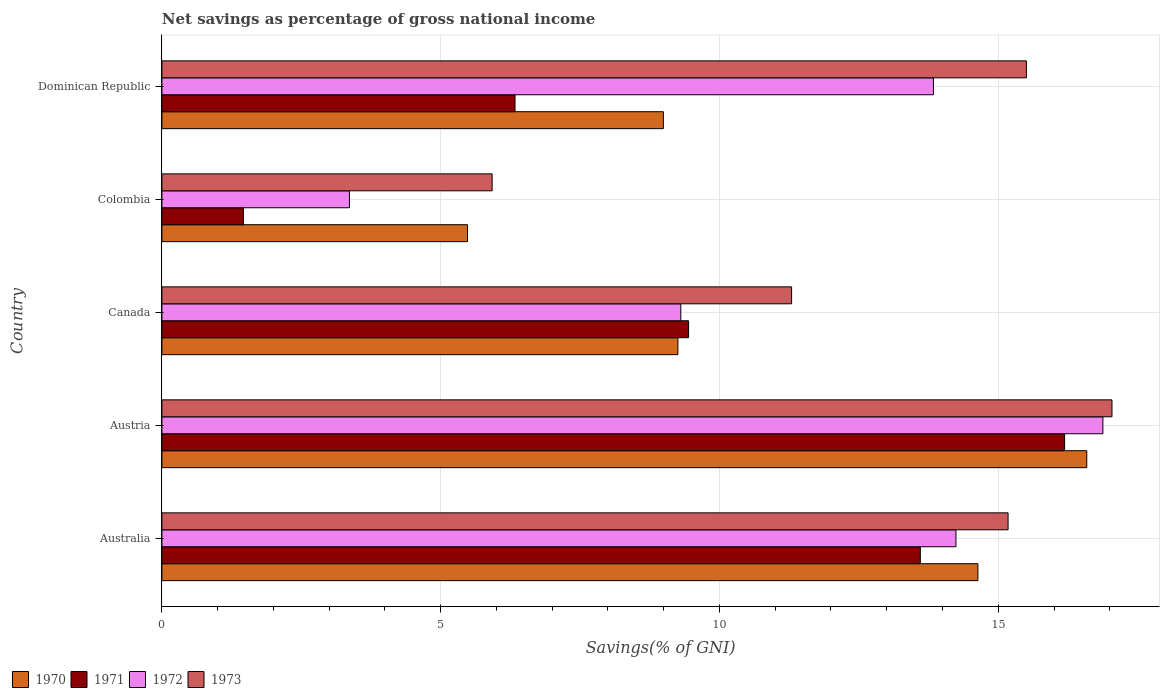How many groups of bars are there?
Give a very brief answer. 5. Are the number of bars per tick equal to the number of legend labels?
Provide a succinct answer. Yes. Are the number of bars on each tick of the Y-axis equal?
Ensure brevity in your answer.  Yes. What is the label of the 1st group of bars from the top?
Offer a terse response. Dominican Republic. What is the total savings in 1973 in Austria?
Your answer should be very brief. 17.04. Across all countries, what is the maximum total savings in 1971?
Make the answer very short. 16.19. Across all countries, what is the minimum total savings in 1970?
Offer a terse response. 5.48. In which country was the total savings in 1971 maximum?
Ensure brevity in your answer.  Austria. In which country was the total savings in 1972 minimum?
Your response must be concise. Colombia. What is the total total savings in 1972 in the graph?
Ensure brevity in your answer.  57.63. What is the difference between the total savings in 1971 in Canada and that in Dominican Republic?
Your response must be concise. 3.11. What is the difference between the total savings in 1972 in Dominican Republic and the total savings in 1970 in Canada?
Your response must be concise. 4.58. What is the average total savings in 1973 per country?
Your answer should be very brief. 12.99. What is the difference between the total savings in 1970 and total savings in 1973 in Dominican Republic?
Provide a short and direct response. -6.51. What is the ratio of the total savings in 1972 in Austria to that in Canada?
Offer a very short reply. 1.81. Is the difference between the total savings in 1970 in Australia and Dominican Republic greater than the difference between the total savings in 1973 in Australia and Dominican Republic?
Provide a succinct answer. Yes. What is the difference between the highest and the second highest total savings in 1972?
Make the answer very short. 2.64. What is the difference between the highest and the lowest total savings in 1970?
Offer a very short reply. 11.11. Is the sum of the total savings in 1970 in Canada and Colombia greater than the maximum total savings in 1971 across all countries?
Provide a succinct answer. No. Is it the case that in every country, the sum of the total savings in 1972 and total savings in 1970 is greater than the sum of total savings in 1971 and total savings in 1973?
Give a very brief answer. No. What does the 4th bar from the top in Austria represents?
Your answer should be compact. 1970. What does the 3rd bar from the bottom in Austria represents?
Provide a succinct answer. 1972. How many bars are there?
Offer a terse response. 20. Are all the bars in the graph horizontal?
Ensure brevity in your answer.  Yes. What is the difference between two consecutive major ticks on the X-axis?
Your answer should be compact. 5. How are the legend labels stacked?
Provide a short and direct response. Horizontal. What is the title of the graph?
Make the answer very short. Net savings as percentage of gross national income. Does "2009" appear as one of the legend labels in the graph?
Your answer should be compact. No. What is the label or title of the X-axis?
Offer a terse response. Savings(% of GNI). What is the Savings(% of GNI) of 1970 in Australia?
Your response must be concise. 14.63. What is the Savings(% of GNI) of 1971 in Australia?
Give a very brief answer. 13.6. What is the Savings(% of GNI) of 1972 in Australia?
Your answer should be very brief. 14.24. What is the Savings(% of GNI) of 1973 in Australia?
Your response must be concise. 15.18. What is the Savings(% of GNI) of 1970 in Austria?
Your answer should be compact. 16.59. What is the Savings(% of GNI) of 1971 in Austria?
Make the answer very short. 16.19. What is the Savings(% of GNI) of 1972 in Austria?
Your response must be concise. 16.88. What is the Savings(% of GNI) in 1973 in Austria?
Offer a terse response. 17.04. What is the Savings(% of GNI) in 1970 in Canada?
Keep it short and to the point. 9.25. What is the Savings(% of GNI) of 1971 in Canada?
Keep it short and to the point. 9.45. What is the Savings(% of GNI) of 1972 in Canada?
Make the answer very short. 9.31. What is the Savings(% of GNI) in 1973 in Canada?
Your answer should be very brief. 11.29. What is the Savings(% of GNI) in 1970 in Colombia?
Make the answer very short. 5.48. What is the Savings(% of GNI) in 1971 in Colombia?
Provide a short and direct response. 1.46. What is the Savings(% of GNI) of 1972 in Colombia?
Provide a succinct answer. 3.36. What is the Savings(% of GNI) in 1973 in Colombia?
Offer a very short reply. 5.92. What is the Savings(% of GNI) in 1970 in Dominican Republic?
Provide a succinct answer. 8.99. What is the Savings(% of GNI) of 1971 in Dominican Republic?
Make the answer very short. 6.33. What is the Savings(% of GNI) in 1972 in Dominican Republic?
Provide a short and direct response. 13.84. What is the Savings(% of GNI) in 1973 in Dominican Republic?
Provide a succinct answer. 15.5. Across all countries, what is the maximum Savings(% of GNI) in 1970?
Your response must be concise. 16.59. Across all countries, what is the maximum Savings(% of GNI) of 1971?
Ensure brevity in your answer.  16.19. Across all countries, what is the maximum Savings(% of GNI) of 1972?
Provide a short and direct response. 16.88. Across all countries, what is the maximum Savings(% of GNI) in 1973?
Offer a terse response. 17.04. Across all countries, what is the minimum Savings(% of GNI) in 1970?
Make the answer very short. 5.48. Across all countries, what is the minimum Savings(% of GNI) of 1971?
Ensure brevity in your answer.  1.46. Across all countries, what is the minimum Savings(% of GNI) of 1972?
Keep it short and to the point. 3.36. Across all countries, what is the minimum Savings(% of GNI) of 1973?
Your response must be concise. 5.92. What is the total Savings(% of GNI) of 1970 in the graph?
Offer a terse response. 54.95. What is the total Savings(% of GNI) of 1971 in the graph?
Ensure brevity in your answer.  47.03. What is the total Savings(% of GNI) in 1972 in the graph?
Ensure brevity in your answer.  57.63. What is the total Savings(% of GNI) of 1973 in the graph?
Give a very brief answer. 64.94. What is the difference between the Savings(% of GNI) in 1970 in Australia and that in Austria?
Provide a short and direct response. -1.95. What is the difference between the Savings(% of GNI) of 1971 in Australia and that in Austria?
Your answer should be compact. -2.59. What is the difference between the Savings(% of GNI) in 1972 in Australia and that in Austria?
Offer a very short reply. -2.64. What is the difference between the Savings(% of GNI) in 1973 in Australia and that in Austria?
Your answer should be very brief. -1.86. What is the difference between the Savings(% of GNI) in 1970 in Australia and that in Canada?
Give a very brief answer. 5.38. What is the difference between the Savings(% of GNI) of 1971 in Australia and that in Canada?
Make the answer very short. 4.16. What is the difference between the Savings(% of GNI) in 1972 in Australia and that in Canada?
Your answer should be very brief. 4.93. What is the difference between the Savings(% of GNI) of 1973 in Australia and that in Canada?
Make the answer very short. 3.88. What is the difference between the Savings(% of GNI) of 1970 in Australia and that in Colombia?
Provide a succinct answer. 9.15. What is the difference between the Savings(% of GNI) in 1971 in Australia and that in Colombia?
Your response must be concise. 12.14. What is the difference between the Savings(% of GNI) in 1972 in Australia and that in Colombia?
Your response must be concise. 10.88. What is the difference between the Savings(% of GNI) in 1973 in Australia and that in Colombia?
Offer a terse response. 9.25. What is the difference between the Savings(% of GNI) in 1970 in Australia and that in Dominican Republic?
Keep it short and to the point. 5.64. What is the difference between the Savings(% of GNI) of 1971 in Australia and that in Dominican Republic?
Your answer should be compact. 7.27. What is the difference between the Savings(% of GNI) of 1972 in Australia and that in Dominican Republic?
Provide a short and direct response. 0.4. What is the difference between the Savings(% of GNI) in 1973 in Australia and that in Dominican Republic?
Give a very brief answer. -0.33. What is the difference between the Savings(% of GNI) in 1970 in Austria and that in Canada?
Keep it short and to the point. 7.33. What is the difference between the Savings(% of GNI) in 1971 in Austria and that in Canada?
Your answer should be compact. 6.74. What is the difference between the Savings(% of GNI) in 1972 in Austria and that in Canada?
Make the answer very short. 7.57. What is the difference between the Savings(% of GNI) in 1973 in Austria and that in Canada?
Offer a very short reply. 5.75. What is the difference between the Savings(% of GNI) in 1970 in Austria and that in Colombia?
Your answer should be very brief. 11.11. What is the difference between the Savings(% of GNI) in 1971 in Austria and that in Colombia?
Make the answer very short. 14.73. What is the difference between the Savings(% of GNI) of 1972 in Austria and that in Colombia?
Provide a short and direct response. 13.51. What is the difference between the Savings(% of GNI) of 1973 in Austria and that in Colombia?
Your answer should be very brief. 11.12. What is the difference between the Savings(% of GNI) in 1970 in Austria and that in Dominican Republic?
Offer a very short reply. 7.59. What is the difference between the Savings(% of GNI) in 1971 in Austria and that in Dominican Republic?
Make the answer very short. 9.86. What is the difference between the Savings(% of GNI) of 1972 in Austria and that in Dominican Republic?
Your response must be concise. 3.04. What is the difference between the Savings(% of GNI) of 1973 in Austria and that in Dominican Republic?
Provide a succinct answer. 1.54. What is the difference between the Savings(% of GNI) of 1970 in Canada and that in Colombia?
Provide a short and direct response. 3.77. What is the difference between the Savings(% of GNI) in 1971 in Canada and that in Colombia?
Make the answer very short. 7.98. What is the difference between the Savings(% of GNI) in 1972 in Canada and that in Colombia?
Provide a short and direct response. 5.94. What is the difference between the Savings(% of GNI) of 1973 in Canada and that in Colombia?
Keep it short and to the point. 5.37. What is the difference between the Savings(% of GNI) of 1970 in Canada and that in Dominican Republic?
Make the answer very short. 0.26. What is the difference between the Savings(% of GNI) of 1971 in Canada and that in Dominican Republic?
Make the answer very short. 3.11. What is the difference between the Savings(% of GNI) of 1972 in Canada and that in Dominican Republic?
Provide a succinct answer. -4.53. What is the difference between the Savings(% of GNI) of 1973 in Canada and that in Dominican Republic?
Offer a terse response. -4.21. What is the difference between the Savings(% of GNI) in 1970 in Colombia and that in Dominican Republic?
Your answer should be very brief. -3.51. What is the difference between the Savings(% of GNI) of 1971 in Colombia and that in Dominican Republic?
Make the answer very short. -4.87. What is the difference between the Savings(% of GNI) in 1972 in Colombia and that in Dominican Republic?
Offer a terse response. -10.47. What is the difference between the Savings(% of GNI) in 1973 in Colombia and that in Dominican Republic?
Make the answer very short. -9.58. What is the difference between the Savings(% of GNI) in 1970 in Australia and the Savings(% of GNI) in 1971 in Austria?
Offer a terse response. -1.55. What is the difference between the Savings(% of GNI) of 1970 in Australia and the Savings(% of GNI) of 1972 in Austria?
Provide a short and direct response. -2.24. What is the difference between the Savings(% of GNI) in 1970 in Australia and the Savings(% of GNI) in 1973 in Austria?
Your answer should be compact. -2.4. What is the difference between the Savings(% of GNI) in 1971 in Australia and the Savings(% of GNI) in 1972 in Austria?
Your answer should be compact. -3.27. What is the difference between the Savings(% of GNI) of 1971 in Australia and the Savings(% of GNI) of 1973 in Austria?
Provide a succinct answer. -3.44. What is the difference between the Savings(% of GNI) in 1972 in Australia and the Savings(% of GNI) in 1973 in Austria?
Make the answer very short. -2.8. What is the difference between the Savings(% of GNI) in 1970 in Australia and the Savings(% of GNI) in 1971 in Canada?
Offer a very short reply. 5.19. What is the difference between the Savings(% of GNI) in 1970 in Australia and the Savings(% of GNI) in 1972 in Canada?
Provide a short and direct response. 5.33. What is the difference between the Savings(% of GNI) in 1970 in Australia and the Savings(% of GNI) in 1973 in Canada?
Keep it short and to the point. 3.34. What is the difference between the Savings(% of GNI) in 1971 in Australia and the Savings(% of GNI) in 1972 in Canada?
Your answer should be very brief. 4.3. What is the difference between the Savings(% of GNI) in 1971 in Australia and the Savings(% of GNI) in 1973 in Canada?
Offer a very short reply. 2.31. What is the difference between the Savings(% of GNI) in 1972 in Australia and the Savings(% of GNI) in 1973 in Canada?
Ensure brevity in your answer.  2.95. What is the difference between the Savings(% of GNI) in 1970 in Australia and the Savings(% of GNI) in 1971 in Colombia?
Keep it short and to the point. 13.17. What is the difference between the Savings(% of GNI) of 1970 in Australia and the Savings(% of GNI) of 1972 in Colombia?
Ensure brevity in your answer.  11.27. What is the difference between the Savings(% of GNI) in 1970 in Australia and the Savings(% of GNI) in 1973 in Colombia?
Provide a short and direct response. 8.71. What is the difference between the Savings(% of GNI) of 1971 in Australia and the Savings(% of GNI) of 1972 in Colombia?
Offer a terse response. 10.24. What is the difference between the Savings(% of GNI) of 1971 in Australia and the Savings(% of GNI) of 1973 in Colombia?
Provide a succinct answer. 7.68. What is the difference between the Savings(% of GNI) of 1972 in Australia and the Savings(% of GNI) of 1973 in Colombia?
Your answer should be compact. 8.32. What is the difference between the Savings(% of GNI) in 1970 in Australia and the Savings(% of GNI) in 1971 in Dominican Republic?
Provide a short and direct response. 8.3. What is the difference between the Savings(% of GNI) of 1970 in Australia and the Savings(% of GNI) of 1972 in Dominican Republic?
Give a very brief answer. 0.8. What is the difference between the Savings(% of GNI) in 1970 in Australia and the Savings(% of GNI) in 1973 in Dominican Republic?
Keep it short and to the point. -0.87. What is the difference between the Savings(% of GNI) in 1971 in Australia and the Savings(% of GNI) in 1972 in Dominican Republic?
Offer a terse response. -0.24. What is the difference between the Savings(% of GNI) in 1971 in Australia and the Savings(% of GNI) in 1973 in Dominican Republic?
Your response must be concise. -1.9. What is the difference between the Savings(% of GNI) of 1972 in Australia and the Savings(% of GNI) of 1973 in Dominican Republic?
Offer a very short reply. -1.26. What is the difference between the Savings(% of GNI) in 1970 in Austria and the Savings(% of GNI) in 1971 in Canada?
Ensure brevity in your answer.  7.14. What is the difference between the Savings(% of GNI) of 1970 in Austria and the Savings(% of GNI) of 1972 in Canada?
Provide a succinct answer. 7.28. What is the difference between the Savings(% of GNI) in 1970 in Austria and the Savings(% of GNI) in 1973 in Canada?
Keep it short and to the point. 5.29. What is the difference between the Savings(% of GNI) of 1971 in Austria and the Savings(% of GNI) of 1972 in Canada?
Your answer should be compact. 6.88. What is the difference between the Savings(% of GNI) of 1971 in Austria and the Savings(% of GNI) of 1973 in Canada?
Make the answer very short. 4.9. What is the difference between the Savings(% of GNI) of 1972 in Austria and the Savings(% of GNI) of 1973 in Canada?
Your answer should be compact. 5.58. What is the difference between the Savings(% of GNI) of 1970 in Austria and the Savings(% of GNI) of 1971 in Colombia?
Offer a very short reply. 15.12. What is the difference between the Savings(% of GNI) of 1970 in Austria and the Savings(% of GNI) of 1972 in Colombia?
Offer a terse response. 13.22. What is the difference between the Savings(% of GNI) of 1970 in Austria and the Savings(% of GNI) of 1973 in Colombia?
Your response must be concise. 10.66. What is the difference between the Savings(% of GNI) of 1971 in Austria and the Savings(% of GNI) of 1972 in Colombia?
Keep it short and to the point. 12.83. What is the difference between the Savings(% of GNI) in 1971 in Austria and the Savings(% of GNI) in 1973 in Colombia?
Keep it short and to the point. 10.27. What is the difference between the Savings(% of GNI) of 1972 in Austria and the Savings(% of GNI) of 1973 in Colombia?
Your answer should be compact. 10.95. What is the difference between the Savings(% of GNI) of 1970 in Austria and the Savings(% of GNI) of 1971 in Dominican Republic?
Provide a succinct answer. 10.25. What is the difference between the Savings(% of GNI) of 1970 in Austria and the Savings(% of GNI) of 1972 in Dominican Republic?
Make the answer very short. 2.75. What is the difference between the Savings(% of GNI) in 1970 in Austria and the Savings(% of GNI) in 1973 in Dominican Republic?
Provide a succinct answer. 1.08. What is the difference between the Savings(% of GNI) of 1971 in Austria and the Savings(% of GNI) of 1972 in Dominican Republic?
Keep it short and to the point. 2.35. What is the difference between the Savings(% of GNI) of 1971 in Austria and the Savings(% of GNI) of 1973 in Dominican Republic?
Give a very brief answer. 0.69. What is the difference between the Savings(% of GNI) in 1972 in Austria and the Savings(% of GNI) in 1973 in Dominican Republic?
Give a very brief answer. 1.37. What is the difference between the Savings(% of GNI) in 1970 in Canada and the Savings(% of GNI) in 1971 in Colombia?
Your answer should be compact. 7.79. What is the difference between the Savings(% of GNI) of 1970 in Canada and the Savings(% of GNI) of 1972 in Colombia?
Provide a succinct answer. 5.89. What is the difference between the Savings(% of GNI) in 1970 in Canada and the Savings(% of GNI) in 1973 in Colombia?
Provide a succinct answer. 3.33. What is the difference between the Savings(% of GNI) in 1971 in Canada and the Savings(% of GNI) in 1972 in Colombia?
Your answer should be compact. 6.08. What is the difference between the Savings(% of GNI) in 1971 in Canada and the Savings(% of GNI) in 1973 in Colombia?
Your answer should be very brief. 3.52. What is the difference between the Savings(% of GNI) in 1972 in Canada and the Savings(% of GNI) in 1973 in Colombia?
Your response must be concise. 3.38. What is the difference between the Savings(% of GNI) of 1970 in Canada and the Savings(% of GNI) of 1971 in Dominican Republic?
Provide a short and direct response. 2.92. What is the difference between the Savings(% of GNI) of 1970 in Canada and the Savings(% of GNI) of 1972 in Dominican Republic?
Your response must be concise. -4.58. What is the difference between the Savings(% of GNI) in 1970 in Canada and the Savings(% of GNI) in 1973 in Dominican Republic?
Make the answer very short. -6.25. What is the difference between the Savings(% of GNI) in 1971 in Canada and the Savings(% of GNI) in 1972 in Dominican Republic?
Keep it short and to the point. -4.39. What is the difference between the Savings(% of GNI) of 1971 in Canada and the Savings(% of GNI) of 1973 in Dominican Republic?
Offer a terse response. -6.06. What is the difference between the Savings(% of GNI) in 1972 in Canada and the Savings(% of GNI) in 1973 in Dominican Republic?
Ensure brevity in your answer.  -6.2. What is the difference between the Savings(% of GNI) in 1970 in Colombia and the Savings(% of GNI) in 1971 in Dominican Republic?
Provide a succinct answer. -0.85. What is the difference between the Savings(% of GNI) of 1970 in Colombia and the Savings(% of GNI) of 1972 in Dominican Republic?
Offer a very short reply. -8.36. What is the difference between the Savings(% of GNI) in 1970 in Colombia and the Savings(% of GNI) in 1973 in Dominican Republic?
Your response must be concise. -10.02. What is the difference between the Savings(% of GNI) of 1971 in Colombia and the Savings(% of GNI) of 1972 in Dominican Republic?
Offer a terse response. -12.38. What is the difference between the Savings(% of GNI) of 1971 in Colombia and the Savings(% of GNI) of 1973 in Dominican Republic?
Your answer should be compact. -14.04. What is the difference between the Savings(% of GNI) of 1972 in Colombia and the Savings(% of GNI) of 1973 in Dominican Republic?
Give a very brief answer. -12.14. What is the average Savings(% of GNI) of 1970 per country?
Provide a short and direct response. 10.99. What is the average Savings(% of GNI) in 1971 per country?
Keep it short and to the point. 9.41. What is the average Savings(% of GNI) of 1972 per country?
Offer a terse response. 11.53. What is the average Savings(% of GNI) in 1973 per country?
Give a very brief answer. 12.99. What is the difference between the Savings(% of GNI) of 1970 and Savings(% of GNI) of 1971 in Australia?
Ensure brevity in your answer.  1.03. What is the difference between the Savings(% of GNI) in 1970 and Savings(% of GNI) in 1972 in Australia?
Provide a short and direct response. 0.39. What is the difference between the Savings(% of GNI) of 1970 and Savings(% of GNI) of 1973 in Australia?
Ensure brevity in your answer.  -0.54. What is the difference between the Savings(% of GNI) in 1971 and Savings(% of GNI) in 1972 in Australia?
Your answer should be compact. -0.64. What is the difference between the Savings(% of GNI) of 1971 and Savings(% of GNI) of 1973 in Australia?
Offer a very short reply. -1.57. What is the difference between the Savings(% of GNI) in 1972 and Savings(% of GNI) in 1973 in Australia?
Give a very brief answer. -0.93. What is the difference between the Savings(% of GNI) in 1970 and Savings(% of GNI) in 1971 in Austria?
Provide a short and direct response. 0.4. What is the difference between the Savings(% of GNI) in 1970 and Savings(% of GNI) in 1972 in Austria?
Make the answer very short. -0.29. What is the difference between the Savings(% of GNI) in 1970 and Savings(% of GNI) in 1973 in Austria?
Offer a terse response. -0.45. What is the difference between the Savings(% of GNI) in 1971 and Savings(% of GNI) in 1972 in Austria?
Your answer should be very brief. -0.69. What is the difference between the Savings(% of GNI) of 1971 and Savings(% of GNI) of 1973 in Austria?
Your response must be concise. -0.85. What is the difference between the Savings(% of GNI) in 1972 and Savings(% of GNI) in 1973 in Austria?
Give a very brief answer. -0.16. What is the difference between the Savings(% of GNI) in 1970 and Savings(% of GNI) in 1971 in Canada?
Provide a short and direct response. -0.19. What is the difference between the Savings(% of GNI) in 1970 and Savings(% of GNI) in 1972 in Canada?
Ensure brevity in your answer.  -0.05. What is the difference between the Savings(% of GNI) in 1970 and Savings(% of GNI) in 1973 in Canada?
Provide a short and direct response. -2.04. What is the difference between the Savings(% of GNI) in 1971 and Savings(% of GNI) in 1972 in Canada?
Offer a very short reply. 0.14. What is the difference between the Savings(% of GNI) in 1971 and Savings(% of GNI) in 1973 in Canada?
Provide a succinct answer. -1.85. What is the difference between the Savings(% of GNI) of 1972 and Savings(% of GNI) of 1973 in Canada?
Offer a terse response. -1.99. What is the difference between the Savings(% of GNI) in 1970 and Savings(% of GNI) in 1971 in Colombia?
Your answer should be very brief. 4.02. What is the difference between the Savings(% of GNI) of 1970 and Savings(% of GNI) of 1972 in Colombia?
Provide a short and direct response. 2.12. What is the difference between the Savings(% of GNI) of 1970 and Savings(% of GNI) of 1973 in Colombia?
Your answer should be very brief. -0.44. What is the difference between the Savings(% of GNI) of 1971 and Savings(% of GNI) of 1972 in Colombia?
Your answer should be compact. -1.9. What is the difference between the Savings(% of GNI) of 1971 and Savings(% of GNI) of 1973 in Colombia?
Your answer should be compact. -4.46. What is the difference between the Savings(% of GNI) in 1972 and Savings(% of GNI) in 1973 in Colombia?
Your answer should be very brief. -2.56. What is the difference between the Savings(% of GNI) of 1970 and Savings(% of GNI) of 1971 in Dominican Republic?
Give a very brief answer. 2.66. What is the difference between the Savings(% of GNI) in 1970 and Savings(% of GNI) in 1972 in Dominican Republic?
Offer a terse response. -4.84. What is the difference between the Savings(% of GNI) of 1970 and Savings(% of GNI) of 1973 in Dominican Republic?
Your answer should be very brief. -6.51. What is the difference between the Savings(% of GNI) in 1971 and Savings(% of GNI) in 1972 in Dominican Republic?
Keep it short and to the point. -7.5. What is the difference between the Savings(% of GNI) in 1971 and Savings(% of GNI) in 1973 in Dominican Republic?
Make the answer very short. -9.17. What is the difference between the Savings(% of GNI) of 1972 and Savings(% of GNI) of 1973 in Dominican Republic?
Your response must be concise. -1.67. What is the ratio of the Savings(% of GNI) of 1970 in Australia to that in Austria?
Give a very brief answer. 0.88. What is the ratio of the Savings(% of GNI) of 1971 in Australia to that in Austria?
Your response must be concise. 0.84. What is the ratio of the Savings(% of GNI) in 1972 in Australia to that in Austria?
Keep it short and to the point. 0.84. What is the ratio of the Savings(% of GNI) of 1973 in Australia to that in Austria?
Offer a very short reply. 0.89. What is the ratio of the Savings(% of GNI) in 1970 in Australia to that in Canada?
Offer a very short reply. 1.58. What is the ratio of the Savings(% of GNI) in 1971 in Australia to that in Canada?
Offer a very short reply. 1.44. What is the ratio of the Savings(% of GNI) of 1972 in Australia to that in Canada?
Offer a terse response. 1.53. What is the ratio of the Savings(% of GNI) in 1973 in Australia to that in Canada?
Your answer should be compact. 1.34. What is the ratio of the Savings(% of GNI) in 1970 in Australia to that in Colombia?
Provide a succinct answer. 2.67. What is the ratio of the Savings(% of GNI) of 1971 in Australia to that in Colombia?
Keep it short and to the point. 9.3. What is the ratio of the Savings(% of GNI) in 1972 in Australia to that in Colombia?
Your answer should be very brief. 4.23. What is the ratio of the Savings(% of GNI) of 1973 in Australia to that in Colombia?
Provide a short and direct response. 2.56. What is the ratio of the Savings(% of GNI) of 1970 in Australia to that in Dominican Republic?
Give a very brief answer. 1.63. What is the ratio of the Savings(% of GNI) in 1971 in Australia to that in Dominican Republic?
Your response must be concise. 2.15. What is the ratio of the Savings(% of GNI) of 1972 in Australia to that in Dominican Republic?
Your answer should be very brief. 1.03. What is the ratio of the Savings(% of GNI) of 1973 in Australia to that in Dominican Republic?
Offer a very short reply. 0.98. What is the ratio of the Savings(% of GNI) of 1970 in Austria to that in Canada?
Provide a succinct answer. 1.79. What is the ratio of the Savings(% of GNI) in 1971 in Austria to that in Canada?
Make the answer very short. 1.71. What is the ratio of the Savings(% of GNI) of 1972 in Austria to that in Canada?
Your response must be concise. 1.81. What is the ratio of the Savings(% of GNI) of 1973 in Austria to that in Canada?
Provide a short and direct response. 1.51. What is the ratio of the Savings(% of GNI) of 1970 in Austria to that in Colombia?
Offer a terse response. 3.03. What is the ratio of the Savings(% of GNI) of 1971 in Austria to that in Colombia?
Give a very brief answer. 11.07. What is the ratio of the Savings(% of GNI) in 1972 in Austria to that in Colombia?
Ensure brevity in your answer.  5.02. What is the ratio of the Savings(% of GNI) of 1973 in Austria to that in Colombia?
Your answer should be very brief. 2.88. What is the ratio of the Savings(% of GNI) in 1970 in Austria to that in Dominican Republic?
Provide a short and direct response. 1.84. What is the ratio of the Savings(% of GNI) in 1971 in Austria to that in Dominican Republic?
Make the answer very short. 2.56. What is the ratio of the Savings(% of GNI) in 1972 in Austria to that in Dominican Republic?
Offer a terse response. 1.22. What is the ratio of the Savings(% of GNI) in 1973 in Austria to that in Dominican Republic?
Make the answer very short. 1.1. What is the ratio of the Savings(% of GNI) of 1970 in Canada to that in Colombia?
Offer a terse response. 1.69. What is the ratio of the Savings(% of GNI) in 1971 in Canada to that in Colombia?
Your response must be concise. 6.46. What is the ratio of the Savings(% of GNI) in 1972 in Canada to that in Colombia?
Make the answer very short. 2.77. What is the ratio of the Savings(% of GNI) in 1973 in Canada to that in Colombia?
Your answer should be very brief. 1.91. What is the ratio of the Savings(% of GNI) in 1970 in Canada to that in Dominican Republic?
Your response must be concise. 1.03. What is the ratio of the Savings(% of GNI) of 1971 in Canada to that in Dominican Republic?
Offer a terse response. 1.49. What is the ratio of the Savings(% of GNI) of 1972 in Canada to that in Dominican Republic?
Keep it short and to the point. 0.67. What is the ratio of the Savings(% of GNI) of 1973 in Canada to that in Dominican Republic?
Keep it short and to the point. 0.73. What is the ratio of the Savings(% of GNI) in 1970 in Colombia to that in Dominican Republic?
Keep it short and to the point. 0.61. What is the ratio of the Savings(% of GNI) of 1971 in Colombia to that in Dominican Republic?
Provide a succinct answer. 0.23. What is the ratio of the Savings(% of GNI) of 1972 in Colombia to that in Dominican Republic?
Make the answer very short. 0.24. What is the ratio of the Savings(% of GNI) in 1973 in Colombia to that in Dominican Republic?
Make the answer very short. 0.38. What is the difference between the highest and the second highest Savings(% of GNI) in 1970?
Your answer should be compact. 1.95. What is the difference between the highest and the second highest Savings(% of GNI) in 1971?
Your response must be concise. 2.59. What is the difference between the highest and the second highest Savings(% of GNI) of 1972?
Offer a very short reply. 2.64. What is the difference between the highest and the second highest Savings(% of GNI) of 1973?
Offer a very short reply. 1.54. What is the difference between the highest and the lowest Savings(% of GNI) in 1970?
Provide a short and direct response. 11.11. What is the difference between the highest and the lowest Savings(% of GNI) of 1971?
Offer a very short reply. 14.73. What is the difference between the highest and the lowest Savings(% of GNI) in 1972?
Offer a very short reply. 13.51. What is the difference between the highest and the lowest Savings(% of GNI) of 1973?
Your response must be concise. 11.12. 